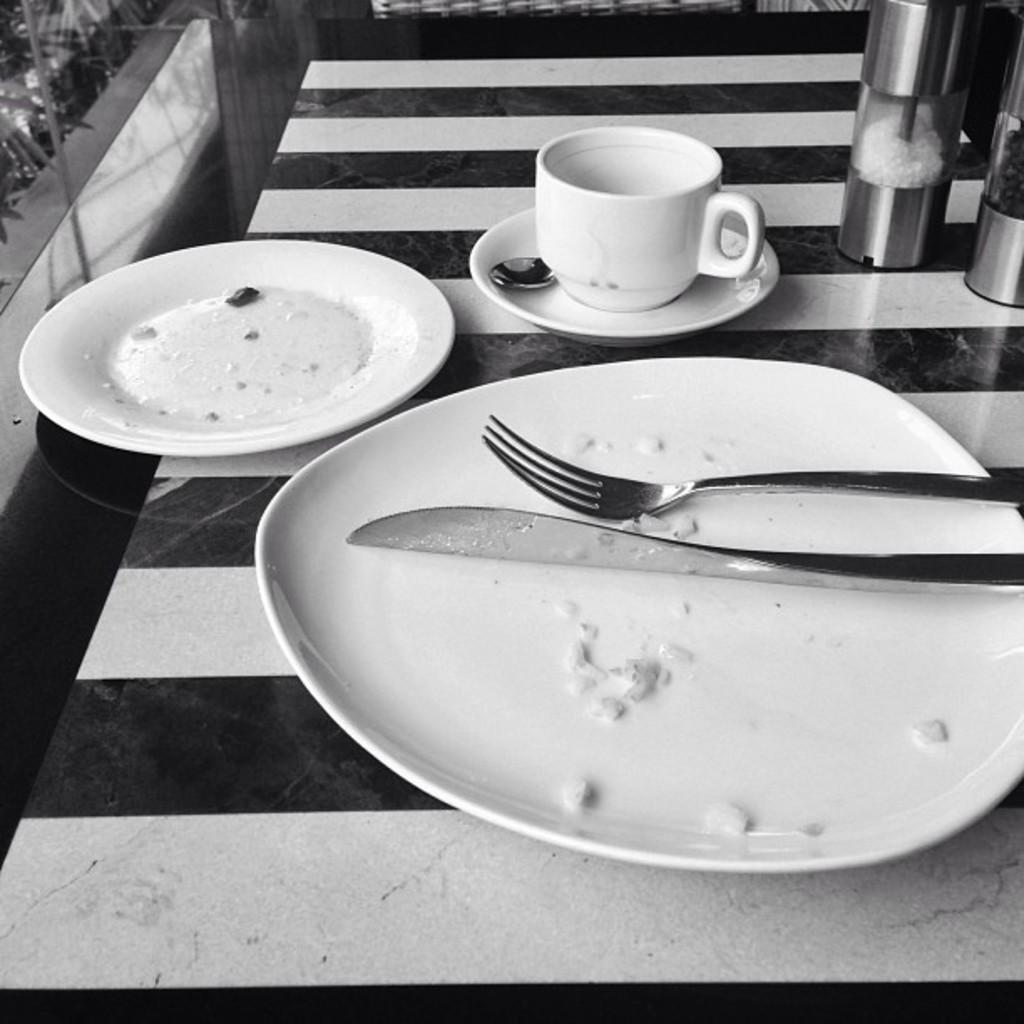What is the color scheme of the image? The image is black and white. What piece of furniture is present in the image? There is a table in the image. What items can be seen on the table? There are plates, forks, knives, a jar, and a cup on the table. What type of scent can be detected from the jar in the image? There is no information about the scent of the jar's contents in the image. What type of cloth is draped over the table in the image? There is no cloth present on the table in the image. 